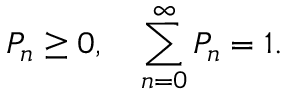<formula> <loc_0><loc_0><loc_500><loc_500>P _ { n } \geq 0 , \quad \sum _ { n = 0 } ^ { \infty } P _ { n } = 1 .</formula> 